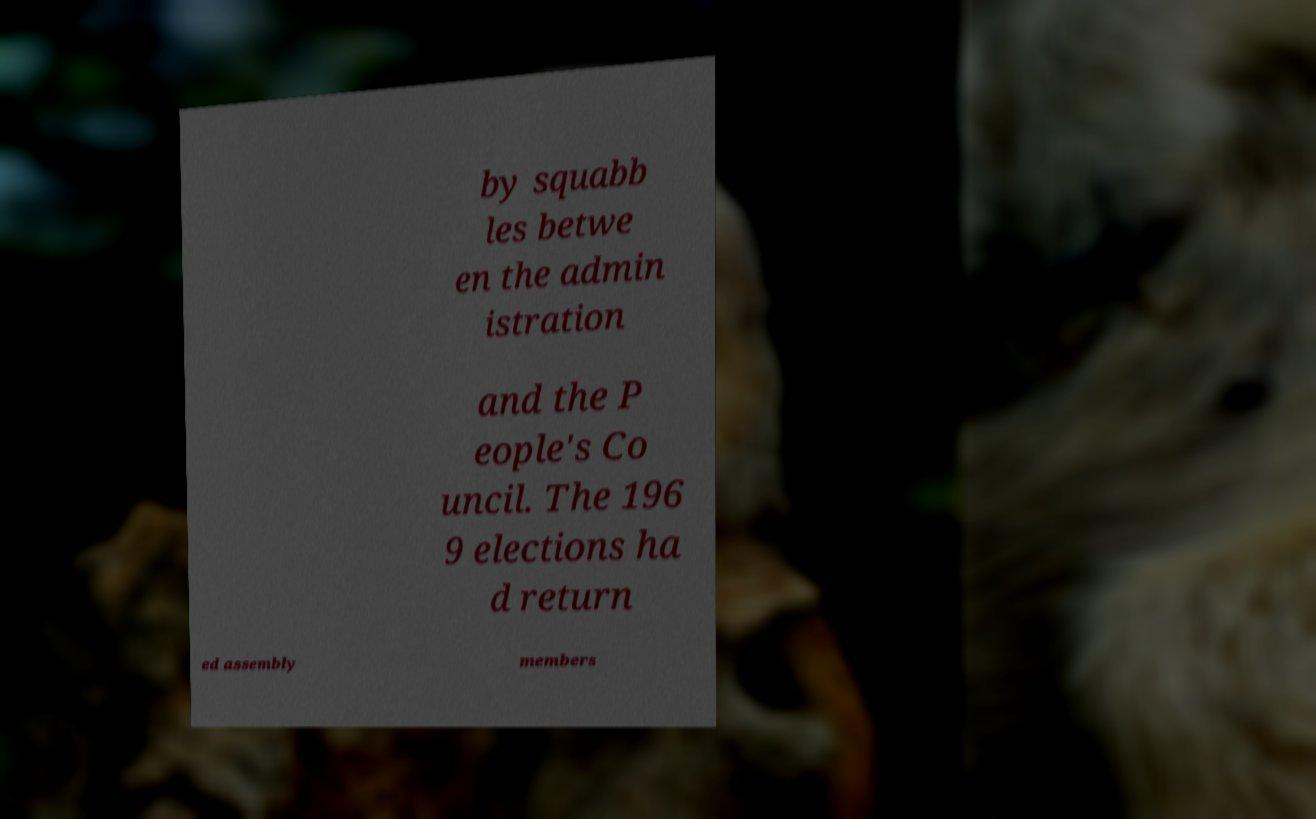Please read and relay the text visible in this image. What does it say? by squabb les betwe en the admin istration and the P eople's Co uncil. The 196 9 elections ha d return ed assembly members 